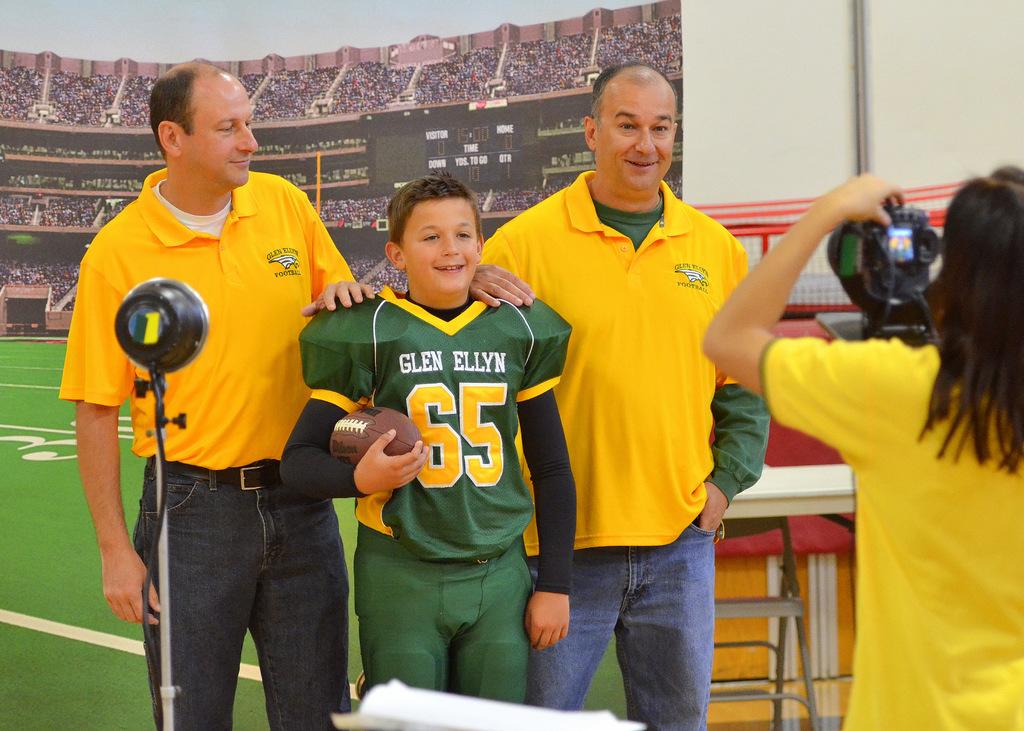What is the player's number?
Keep it short and to the point. 65. What football player's name is on the green shirt?
Ensure brevity in your answer.  Glen ellyn. 